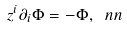<formula> <loc_0><loc_0><loc_500><loc_500>z ^ { i } \partial _ { i } \Phi = - \Phi , \ n n</formula> 